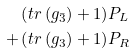<formula> <loc_0><loc_0><loc_500><loc_500>\left ( t r \left ( g _ { \bar { 3 } } \right ) + 1 \right ) & P _ { L } \\ + \left ( t r \left ( g _ { 3 } \right ) + 1 \right ) & P _ { R }</formula> 